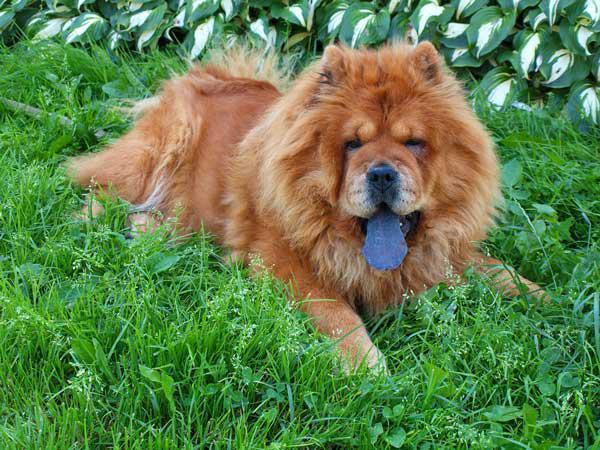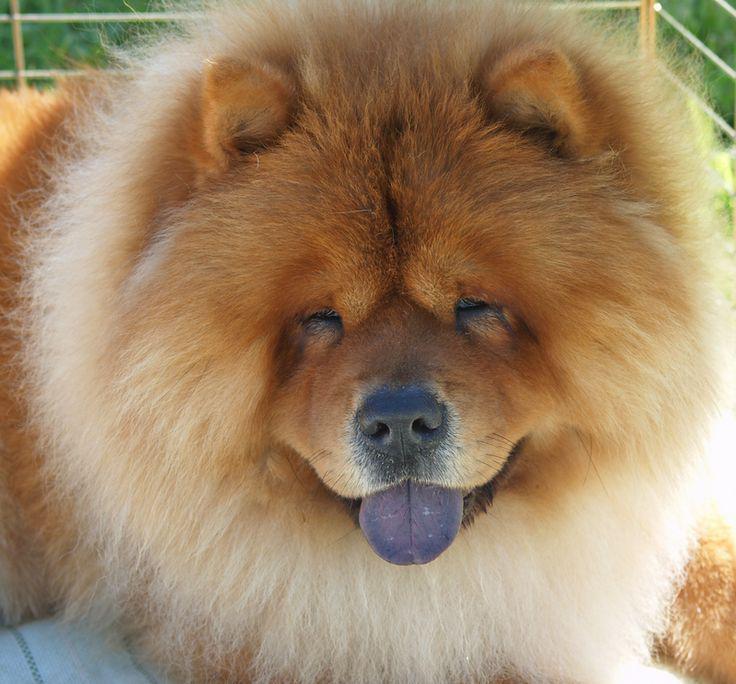The first image is the image on the left, the second image is the image on the right. Given the left and right images, does the statement "Two dogs have their mouths open and tongues sticking out." hold true? Answer yes or no. Yes. The first image is the image on the left, the second image is the image on the right. Evaluate the accuracy of this statement regarding the images: "The dogs in both images are sticking their tongues out.". Is it true? Answer yes or no. Yes. 